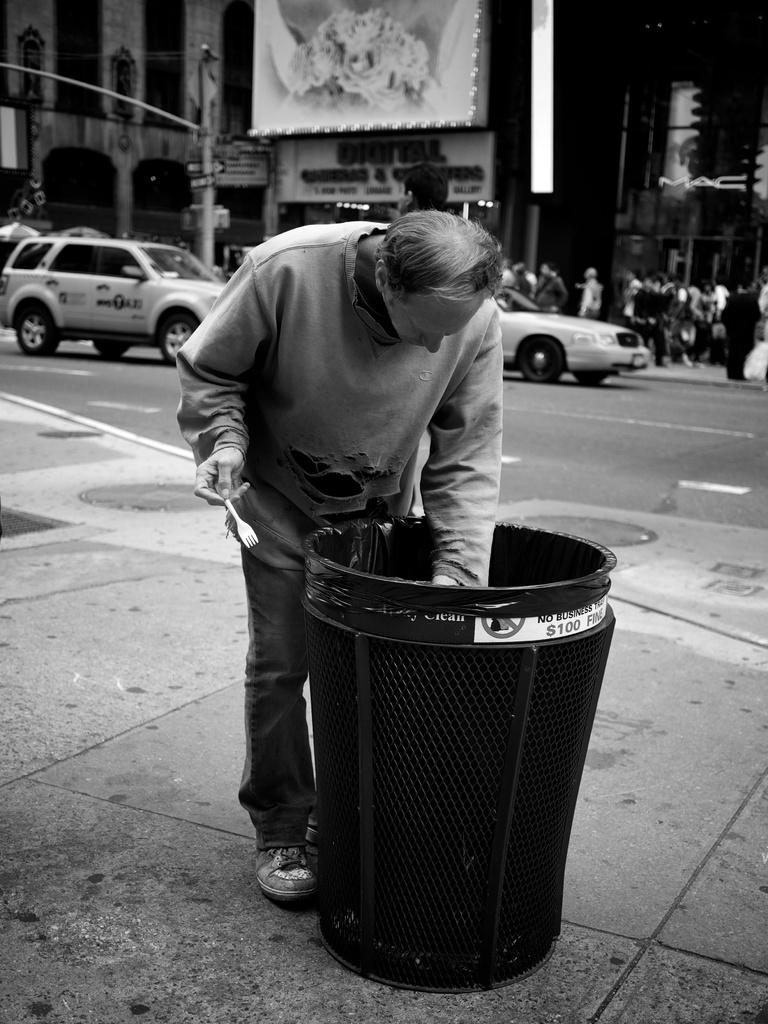How much is the fine listed on the trash can?
Give a very brief answer. $100. 